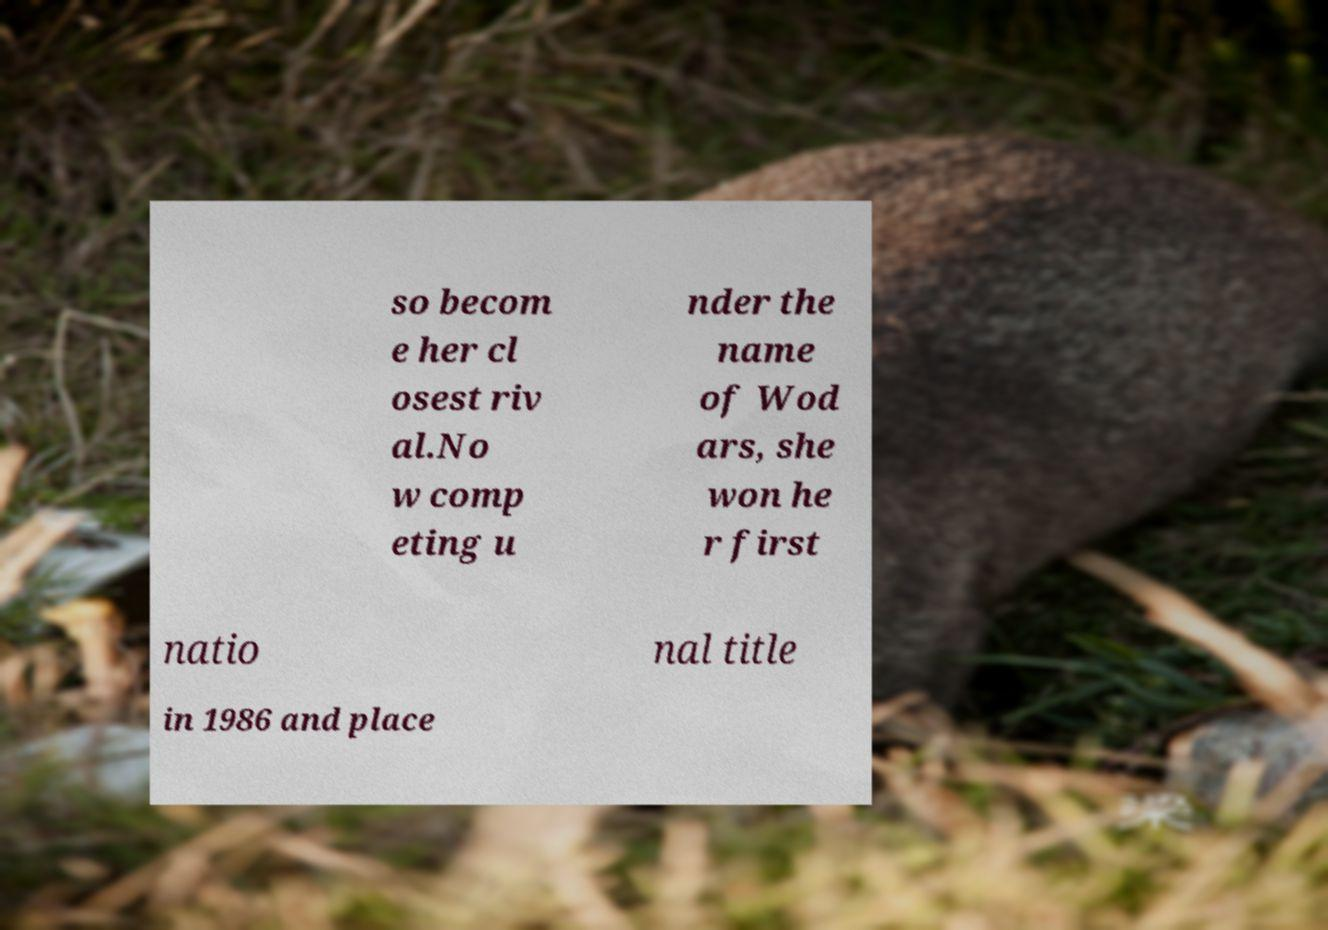There's text embedded in this image that I need extracted. Can you transcribe it verbatim? so becom e her cl osest riv al.No w comp eting u nder the name of Wod ars, she won he r first natio nal title in 1986 and place 